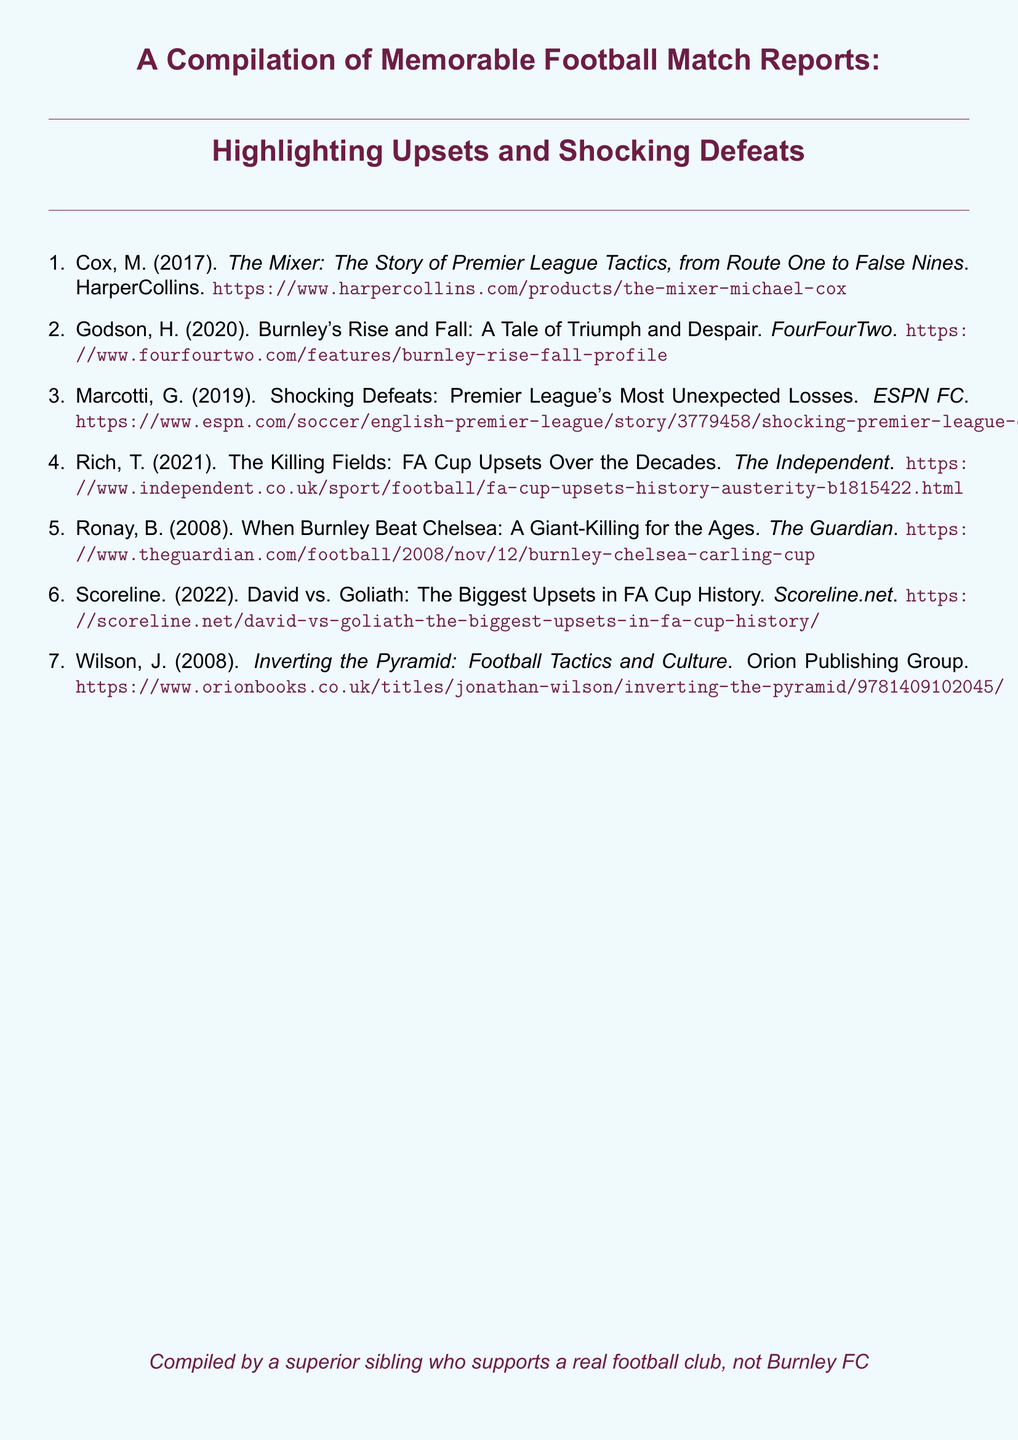What is the title of the document? The title summarizes the content of the document, which compiles memorable football match reports.
Answer: A Compilation of Memorable Football Match Reports: Highlighting Upsets and Shocking Defeats Who is the author of "The Mixer"? This question asks for the author of a specific book mentioned in the document.
Answer: Michael Cox What year was "Burnley's Rise and Fall" published? This question seeks the publication year of a specific work listed in the document.
Answer: 2020 How many match reports are compiled in the bibliography? This question requires counting the number of entries in the enumerated list within the document.
Answer: 7 Which publication featured the article "When Burnley Beat Chelsea"? This question asks for the source of the specific match report mentioned in the document.
Answer: The Guardian What color is the background of the document? This question pertains to the document's visual design aspect rather than its content.
Answer: Light blue Who compiled the document? This question seeks information about the compiler of the compilation.
Answer: A superior sibling who supports a real football club, not Burnley FC 